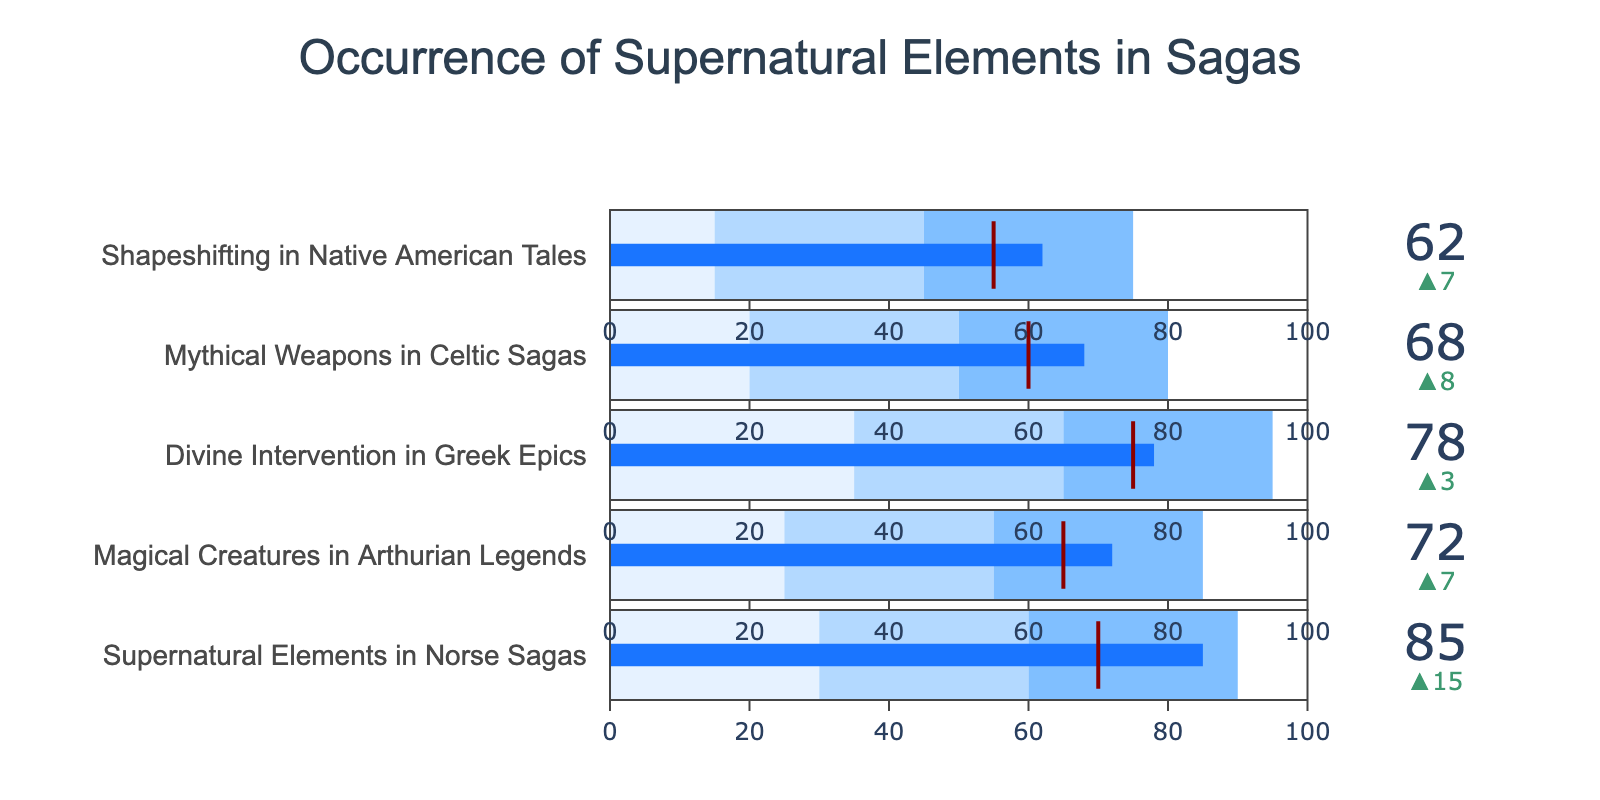What is the title of the chart? The title is located at the top center of the figure and is explicitly stated.
Answer: Occurrence of Supernatural Elements in Sagas How many sagas are compared in this chart? The figure contains five separate bullet charts, each representing a different saga.
Answer: 5 Which saga has the highest actual occurrence of supernatural elements? By looking at the highest value across all bullet charts, it is clear that "Supernatural Elements in Norse Sagas" have the highest actual value.
Answer: Supernatural Elements in Norse Sagas Which saga's actual occurrence of supernatural elements is closest to the genre average? To find the closest actual value to the comparative value within each saga, "Divine Intervention in Greek Epics" has an actual value of 78 and a comparative value of 75, making it the closest.
Answer: Divine Intervention in Greek Epics Among all the sagas, which one has the largest difference between actual occurrence and genre average? Calculate the difference between 'Actual' and 'Comparative' for each saga. The largest difference is 15 (85 - 70) for "Supernatural Elements in Norse Sagas".
Answer: Supernatural Elements in Norse Sagas What is the range of occurrence values for "Magical Creatures in Arthurian Legends"? The ranges are indicated by the colors in the bullet chart, and for "Magical Creatures in Arthurian Legends" it is specified as 25 to 85.
Answer: 25 to 85 Compare the actual occurrences of supernatural elements in "Mythical Weapons in Celtic Sagas" and "Shapeshifting in Native American Tales". Which has more? "Mythical Weapons in Celtic Sagas" has an actual value of 68 while "Shapeshifting in Native American Tales" has an actual value of 62. Thus, "Mythical Weapons in Celtic Sagas" has a higher occurrence.
Answer: Mythical Weapons in Celtic Sagas What is the difference between the actual occurrence of supernatural elements in "Supernatural Elements in Norse Sagas" and "Magical Creatures in Arthurian Legends"? Subtract the actual value of "Magical Creatures in Arthurian Legends" (72) from "Supernatural Elements in Norse Sagas" (85). The difference is 13.
Answer: 13 Which sagas have an actual occurrence value that exceeds their comparative (genre average) value? By comparing actual and comparative values for each saga, the sagas that exceed their averages are "Supernatural Elements in Norse Sagas", "Magical Creatures in Arthurian Legends", and "Divine Intervention in Greek Epics".
Answer: Supernatural Elements in Norse Sagas, Magical Creatures in Arthurian Legends, Divine Intervention in Greek Epics 